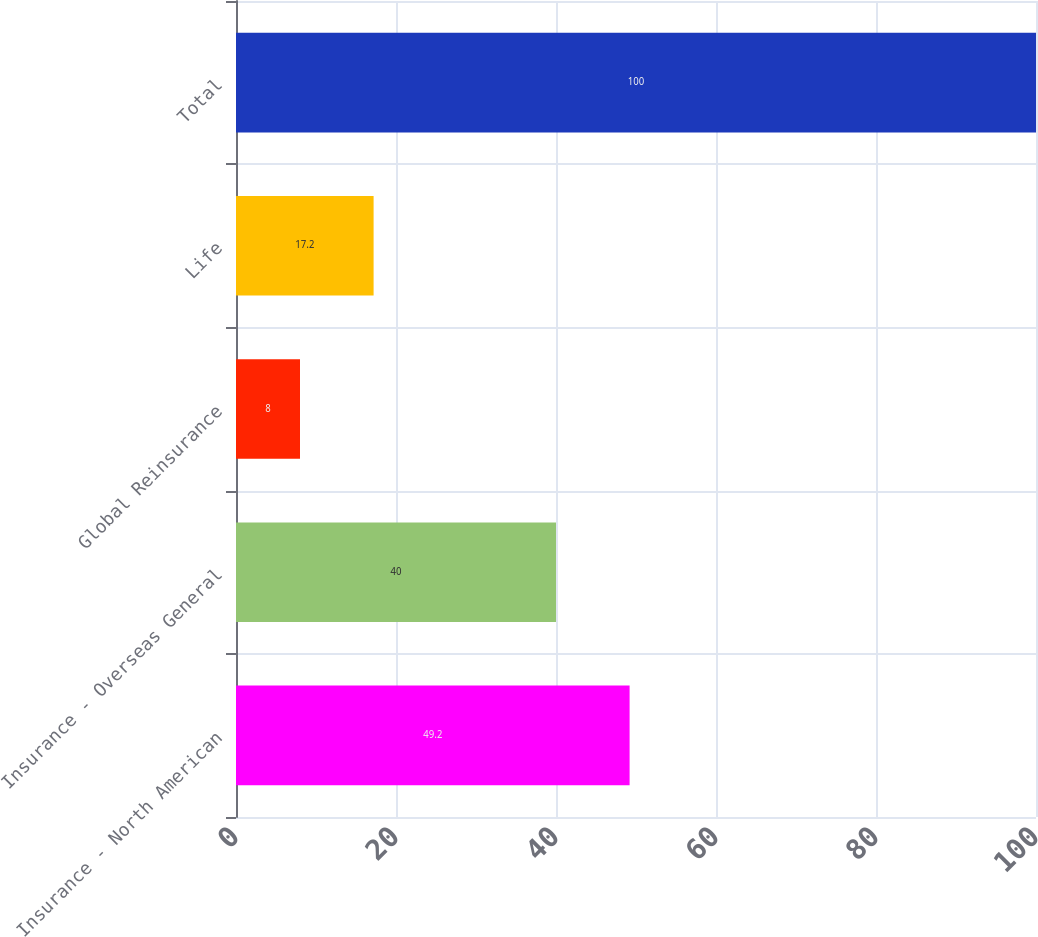Convert chart. <chart><loc_0><loc_0><loc_500><loc_500><bar_chart><fcel>Insurance - North American<fcel>Insurance - Overseas General<fcel>Global Reinsurance<fcel>Life<fcel>Total<nl><fcel>49.2<fcel>40<fcel>8<fcel>17.2<fcel>100<nl></chart> 